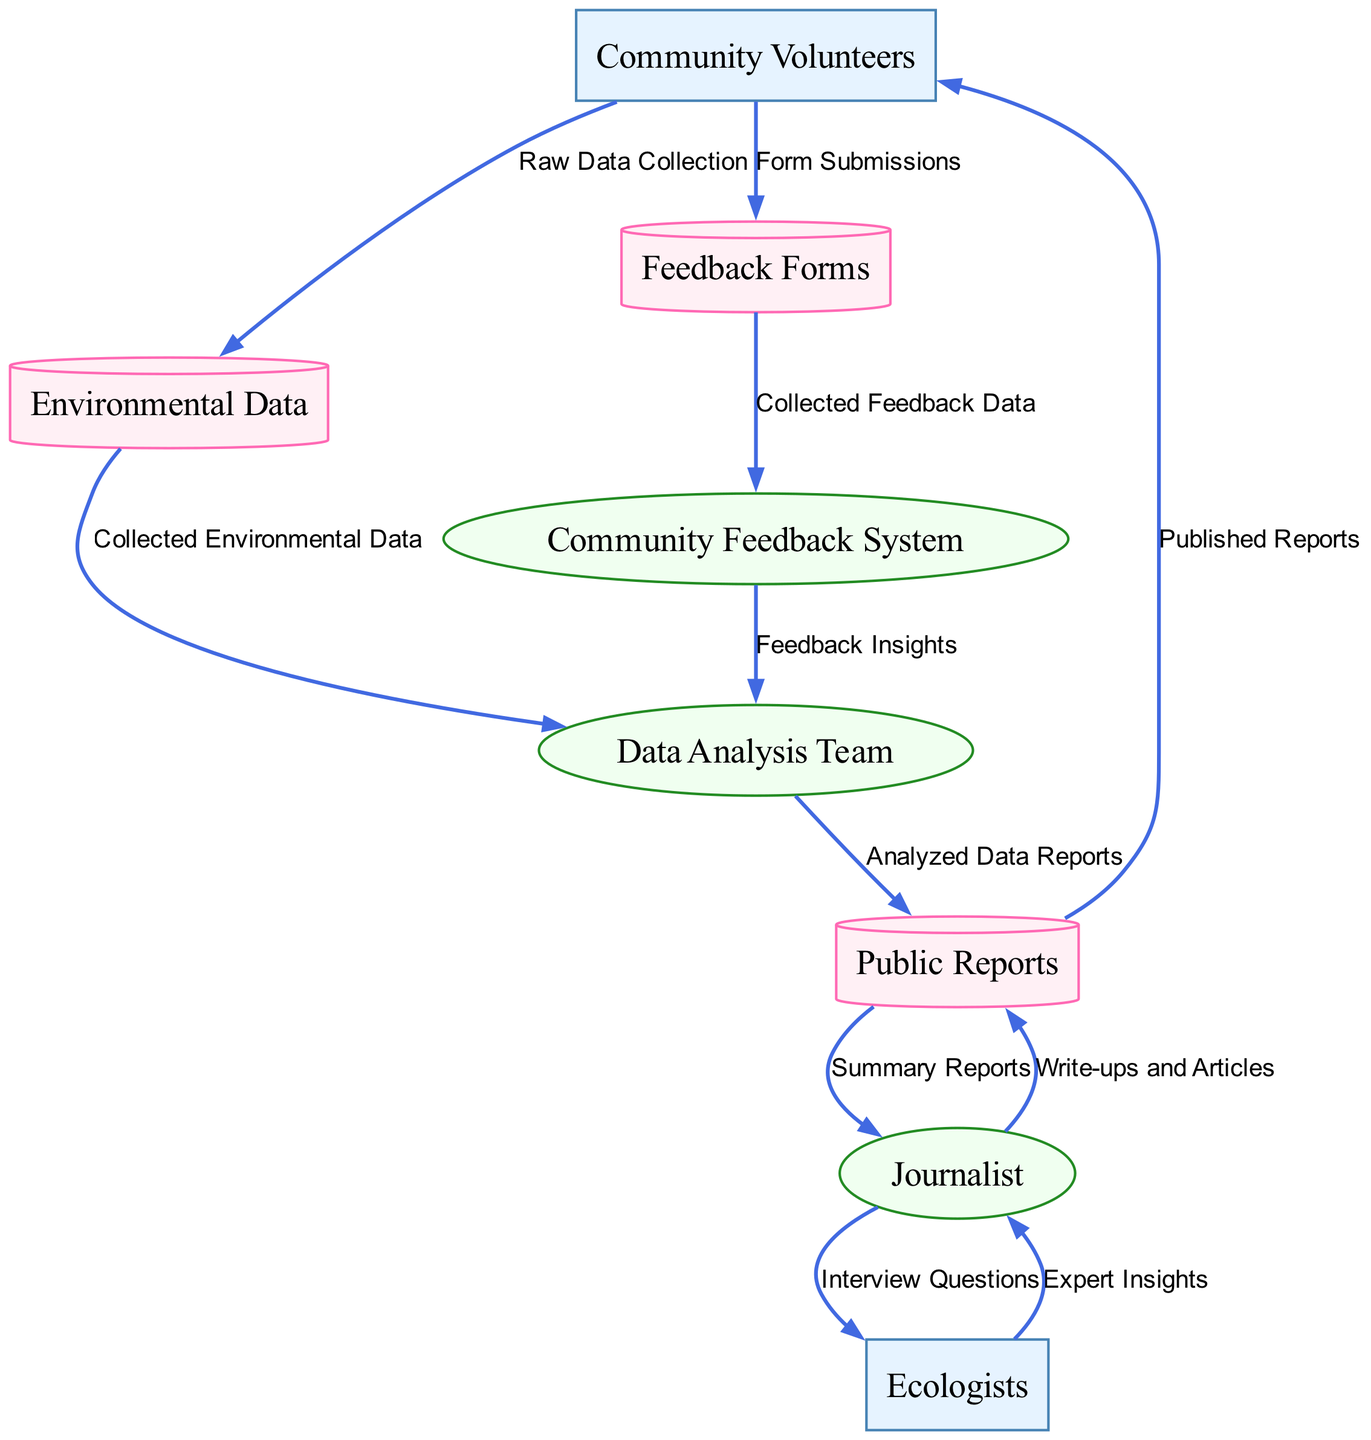What is the first step in the process depicted in the diagram? The first step is the collection of raw data by Community Volunteers, which is represented by the arrow flowing from Community Volunteers to Environmental Data.
Answer: Raw Data Collection How many external entities are represented in the diagram? The diagram shows two external entities: Community Volunteers and Ecologists. This can be determined by counting the nodes labeled as external entities.
Answer: Two What does the Data Analysis Team receive from the Environmental Data? The Data Analysis Team receives the collected environmental data, as indicated by the arrow from Environmental Data leading to the Data Analysis Team.
Answer: Collected Environmental Data Which process receives feedback insights? The Community Feedback System receives feedback insights, as depicted by the flow of data from the Feedback Forms to the Community Feedback System.
Answer: Community Feedback System How many data stores are indicated in the diagram? There are three data stores shown in the diagram: Environmental Data, Public Reports, and Feedback Forms. This can be confirmed by counting the nodes categorized as data stores.
Answer: Three What type of data do Community Volunteers submit? Community Volunteers submit form submissions, as represented by the flow from Community Volunteers to Feedback Forms labeled as such.
Answer: Form Submissions What does the Journalist provide to the Ecologists? The Journalist provides interview questions to the Ecologists, denoted by the data flow from Journalist to Ecologists labeled as such.
Answer: Interview Questions Which process analyzes the collected environmental data? The Data Analysis Team is responsible for analyzing the collected environmental data, as indicated by the arrow flowing from Environmental Data to Data Analysis Team.
Answer: Data Analysis Team What happens to analyzed data reports after being created? Analyzed data reports are sent to Public Reports, represented by the flow from the Data Analysis Team to Public Reports.
Answer: Public Reports 